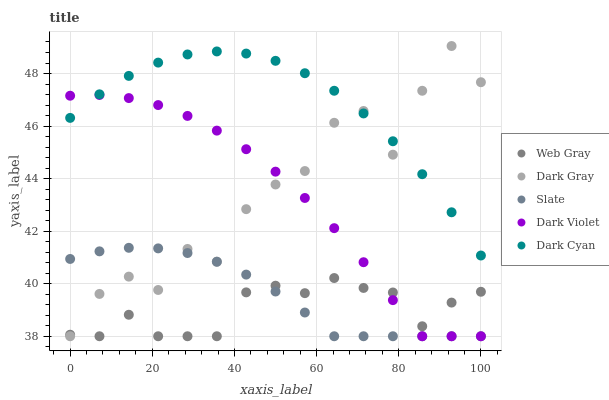Does Web Gray have the minimum area under the curve?
Answer yes or no. Yes. Does Dark Cyan have the maximum area under the curve?
Answer yes or no. Yes. Does Slate have the minimum area under the curve?
Answer yes or no. No. Does Slate have the maximum area under the curve?
Answer yes or no. No. Is Slate the smoothest?
Answer yes or no. Yes. Is Dark Gray the roughest?
Answer yes or no. Yes. Is Dark Cyan the smoothest?
Answer yes or no. No. Is Dark Cyan the roughest?
Answer yes or no. No. Does Dark Gray have the lowest value?
Answer yes or no. Yes. Does Dark Cyan have the lowest value?
Answer yes or no. No. Does Dark Gray have the highest value?
Answer yes or no. Yes. Does Dark Cyan have the highest value?
Answer yes or no. No. Is Web Gray less than Dark Cyan?
Answer yes or no. Yes. Is Dark Cyan greater than Slate?
Answer yes or no. Yes. Does Web Gray intersect Dark Violet?
Answer yes or no. Yes. Is Web Gray less than Dark Violet?
Answer yes or no. No. Is Web Gray greater than Dark Violet?
Answer yes or no. No. Does Web Gray intersect Dark Cyan?
Answer yes or no. No. 